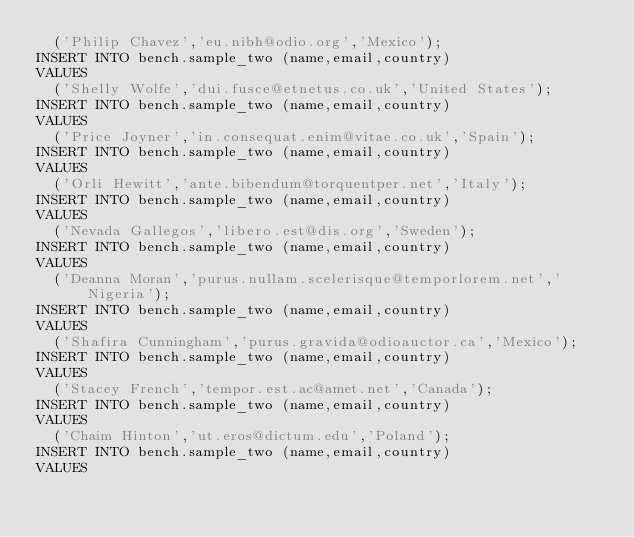Convert code to text. <code><loc_0><loc_0><loc_500><loc_500><_SQL_>  ('Philip Chavez','eu.nibh@odio.org','Mexico');
INSERT INTO bench.sample_two (name,email,country)
VALUES
  ('Shelly Wolfe','dui.fusce@etnetus.co.uk','United States');
INSERT INTO bench.sample_two (name,email,country)
VALUES
  ('Price Joyner','in.consequat.enim@vitae.co.uk','Spain');
INSERT INTO bench.sample_two (name,email,country)
VALUES
  ('Orli Hewitt','ante.bibendum@torquentper.net','Italy');
INSERT INTO bench.sample_two (name,email,country)
VALUES
  ('Nevada Gallegos','libero.est@dis.org','Sweden');
INSERT INTO bench.sample_two (name,email,country)
VALUES
  ('Deanna Moran','purus.nullam.scelerisque@temporlorem.net','Nigeria');
INSERT INTO bench.sample_two (name,email,country)
VALUES
  ('Shafira Cunningham','purus.gravida@odioauctor.ca','Mexico');
INSERT INTO bench.sample_two (name,email,country)
VALUES
  ('Stacey French','tempor.est.ac@amet.net','Canada');
INSERT INTO bench.sample_two (name,email,country)
VALUES
  ('Chaim Hinton','ut.eros@dictum.edu','Poland');
INSERT INTO bench.sample_two (name,email,country)
VALUES</code> 